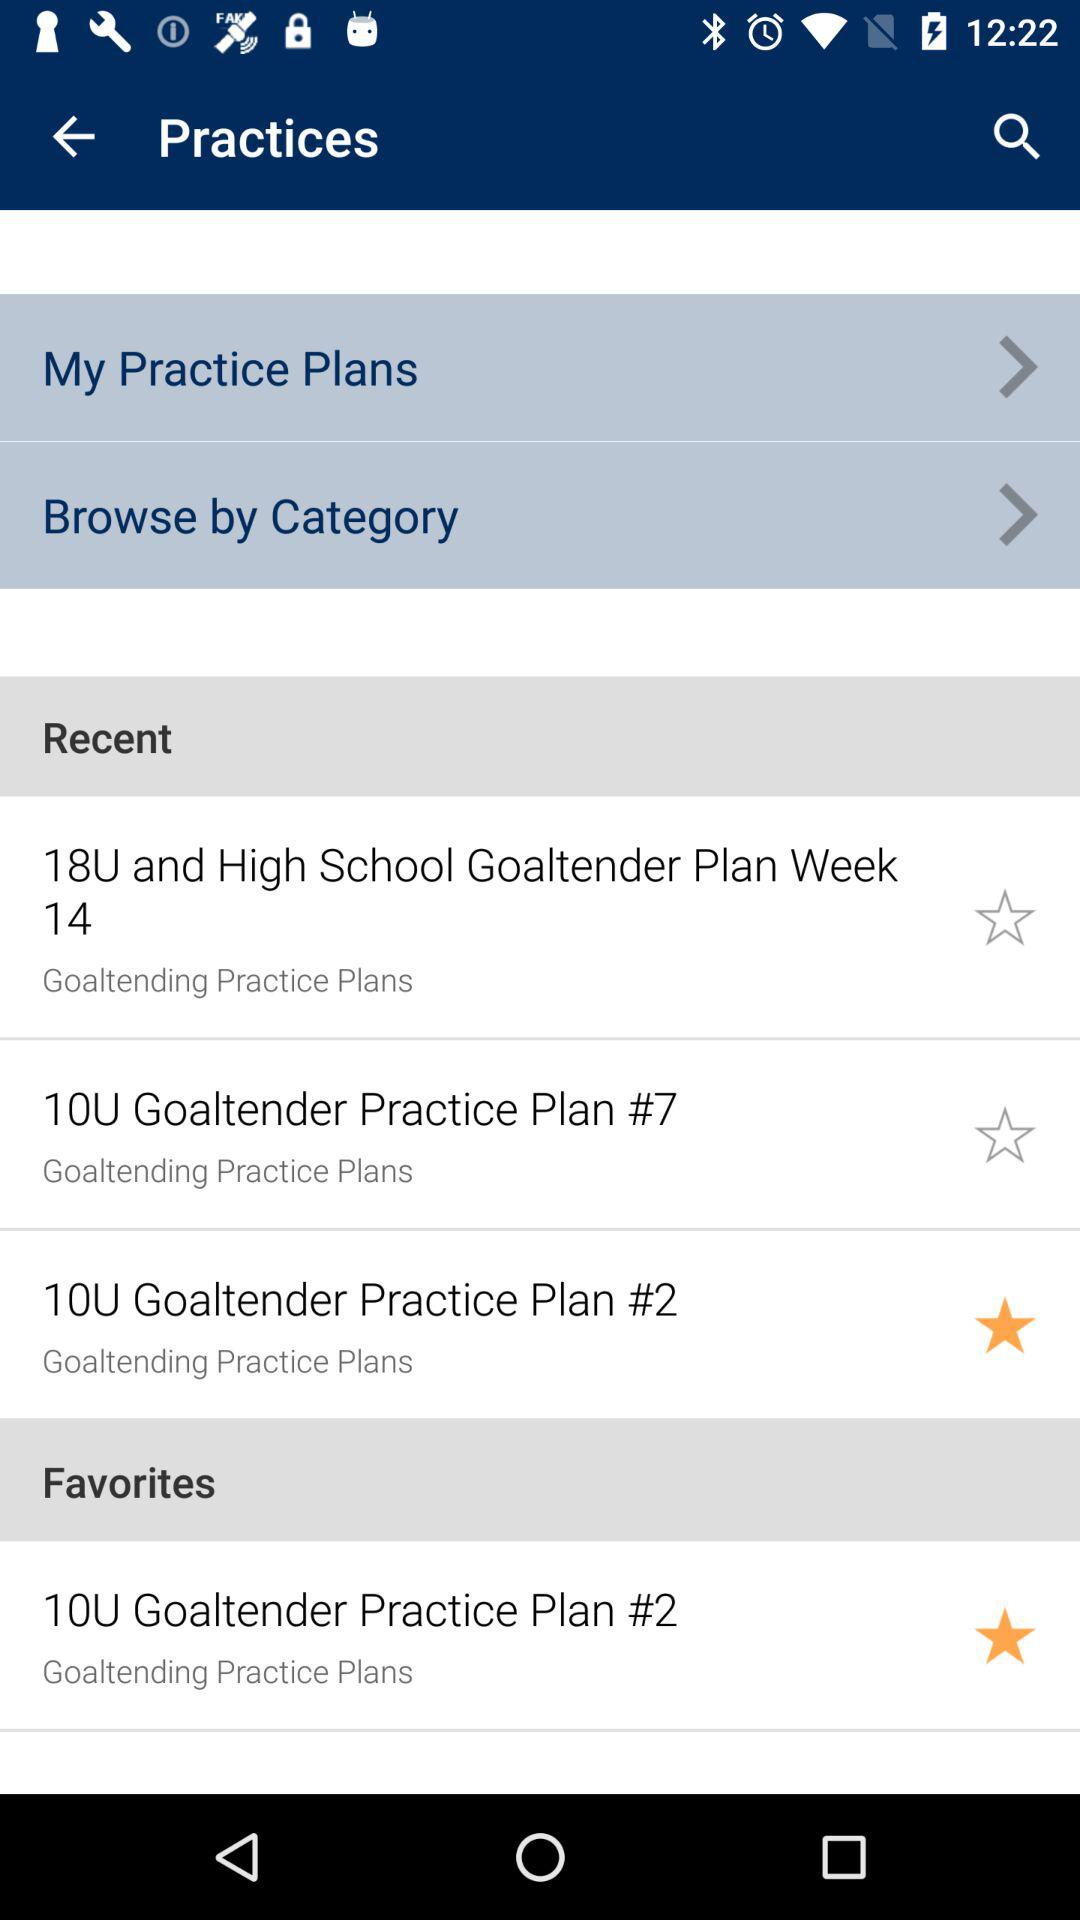How many practice plans are in the Goaltending Practice Plans category?
Answer the question using a single word or phrase. 3 